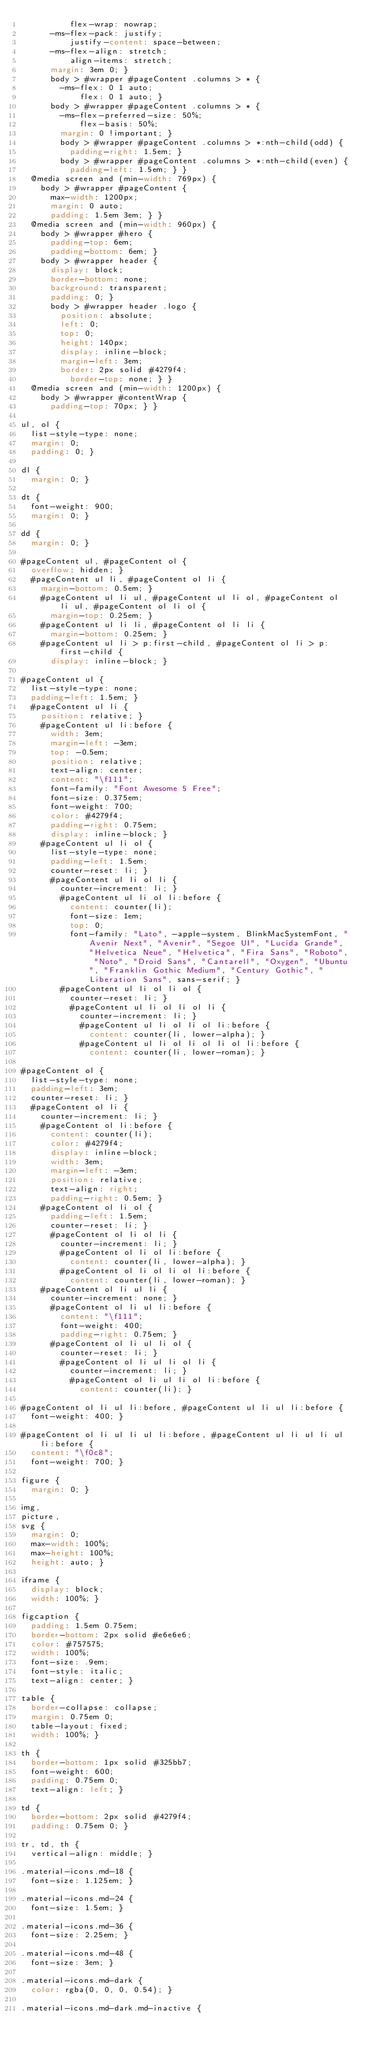<code> <loc_0><loc_0><loc_500><loc_500><_CSS_>          flex-wrap: nowrap;
      -ms-flex-pack: justify;
          justify-content: space-between;
      -ms-flex-align: stretch;
          align-items: stretch;
      margin: 3em 0; }
      body > #wrapper #pageContent .columns > * {
        -ms-flex: 0 1 auto;
            flex: 0 1 auto; }
      body > #wrapper #pageContent .columns > * {
        -ms-flex-preferred-size: 50%;
            flex-basis: 50%;
        margin: 0 !important; }
        body > #wrapper #pageContent .columns > *:nth-child(odd) {
          padding-right: 1.5em; }
        body > #wrapper #pageContent .columns > *:nth-child(even) {
          padding-left: 1.5em; } }
  @media screen and (min-width: 769px) {
    body > #wrapper #pageContent {
      max-width: 1200px;
      margin: 0 auto;
      padding: 1.5em 3em; } }
  @media screen and (min-width: 960px) {
    body > #wrapper #hero {
      padding-top: 6em;
      padding-bottom: 6em; }
    body > #wrapper header {
      display: block;
      border-bottom: none;
      background: transparent;
      padding: 0; }
      body > #wrapper header .logo {
        position: absolute;
        left: 0;
        top: 0;
        height: 140px;
        display: inline-block;
        margin-left: 3em;
        border: 2px solid #4279f4;
          border-top: none; } }
  @media screen and (min-width: 1200px) {
    body > #wrapper #contentWrap {
      padding-top: 70px; } }

ul, ol {
  list-style-type: none;
  margin: 0;
  padding: 0; }

dl {
  margin: 0; }

dt {
  font-weight: 900;
  margin: 0; }

dd {
  margin: 0; }

#pageContent ul, #pageContent ol {
  overflow: hidden; }
  #pageContent ul li, #pageContent ol li {
    margin-bottom: 0.5em; }
    #pageContent ul li ul, #pageContent ul li ol, #pageContent ol li ul, #pageContent ol li ol {
      margin-top: 0.25em; }
    #pageContent ul li li, #pageContent ol li li {
      margin-bottom: 0.25em; }
    #pageContent ul li > p:first-child, #pageContent ol li > p:first-child {
      display: inline-block; }

#pageContent ul {
  list-style-type: none;
  padding-left: 1.5em; }
  #pageContent ul li {
    position: relative; }
    #pageContent ul li:before {
      width: 3em;
      margin-left: -3em;
      top: -0.5em;
      position: relative;
      text-align: center;
      content: "\f111";
      font-family: "Font Awesome 5 Free";
      font-size: 0.375em;
      font-weight: 700;
      color: #4279f4;
      padding-right: 0.75em;
      display: inline-block; }
    #pageContent ul li ol {
      list-style-type: none;
      padding-left: 1.5em;
      counter-reset: li; }
      #pageContent ul li ol li {
        counter-increment: li; }
        #pageContent ul li ol li:before {
          content: counter(li);
          font-size: 1em;
          top: 0;
          font-family: "Lato", -apple-system, BlinkMacSystemFont, "Avenir Next", "Avenir", "Segoe UI", "Lucida Grande", "Helvetica Neue", "Helvetica", "Fira Sans", "Roboto", "Noto", "Droid Sans", "Cantarell", "Oxygen", "Ubuntu", "Franklin Gothic Medium", "Century Gothic", "Liberation Sans", sans-serif; }
        #pageContent ul li ol li ol {
          counter-reset: li; }
          #pageContent ul li ol li ol li {
            counter-increment: li; }
            #pageContent ul li ol li ol li:before {
              content: counter(li, lower-alpha); }
            #pageContent ul li ol li ol li ol li:before {
              content: counter(li, lower-roman); }

#pageContent ol {
  list-style-type: none;
  padding-left: 3em;
  counter-reset: li; }
  #pageContent ol li {
    counter-increment: li; }
    #pageContent ol li:before {
      content: counter(li);
      color: #4279f4;
      display: inline-block;
      width: 3em;
      margin-left: -3em;
      position: relative;
      text-align: right;
      padding-right: 0.5em; }
    #pageContent ol li ol {
      padding-left: 1.5em;
      counter-reset: li; }
      #pageContent ol li ol li {
        counter-increment: li; }
        #pageContent ol li ol li:before {
          content: counter(li, lower-alpha); }
        #pageContent ol li ol li ol li:before {
          content: counter(li, lower-roman); }
    #pageContent ol li ul li {
      counter-increment: none; }
      #pageContent ol li ul li:before {
        content: "\f111";
        font-weight: 400;
        padding-right: 0.75em; }
      #pageContent ol li ul li ol {
        counter-reset: li; }
        #pageContent ol li ul li ol li {
          counter-increment: li; }
          #pageContent ol li ul li ol li:before {
            content: counter(li); }

#pageContent ol li ul li:before, #pageContent ul li ul li:before {
  font-weight: 400; }

#pageContent ol li ul li ul li:before, #pageContent ul li ul li ul li:before {
  content: "\f0c8";
  font-weight: 700; }

figure {
  margin: 0; }

img,
picture,
svg {
  margin: 0;
  max-width: 100%;
  max-height: 100%;
  height: auto; }

iframe {
  display: block;
  width: 100%; }

figcaption {
  padding: 1.5em 0.75em;
  border-bottom: 2px solid #e6e6e6;
  color: #757575;
  width: 100%;
  font-size: .9em;
  font-style: italic;
  text-align: center; }

table {
  border-collapse: collapse;
  margin: 0.75em 0;
  table-layout: fixed;
  width: 100%; }

th {
  border-bottom: 1px solid #325bb7;
  font-weight: 600;
  padding: 0.75em 0;
  text-align: left; }

td {
  border-bottom: 2px solid #4279f4;
  padding: 0.75em 0; }

tr, td, th {
  vertical-align: middle; }

.material-icons.md-18 {
  font-size: 1.125em; }

.material-icons.md-24 {
  font-size: 1.5em; }

.material-icons.md-36 {
  font-size: 2.25em; }

.material-icons.md-48 {
  font-size: 3em; }

.material-icons.md-dark {
  color: rgba(0, 0, 0, 0.54); }

.material-icons.md-dark.md-inactive {</code> 